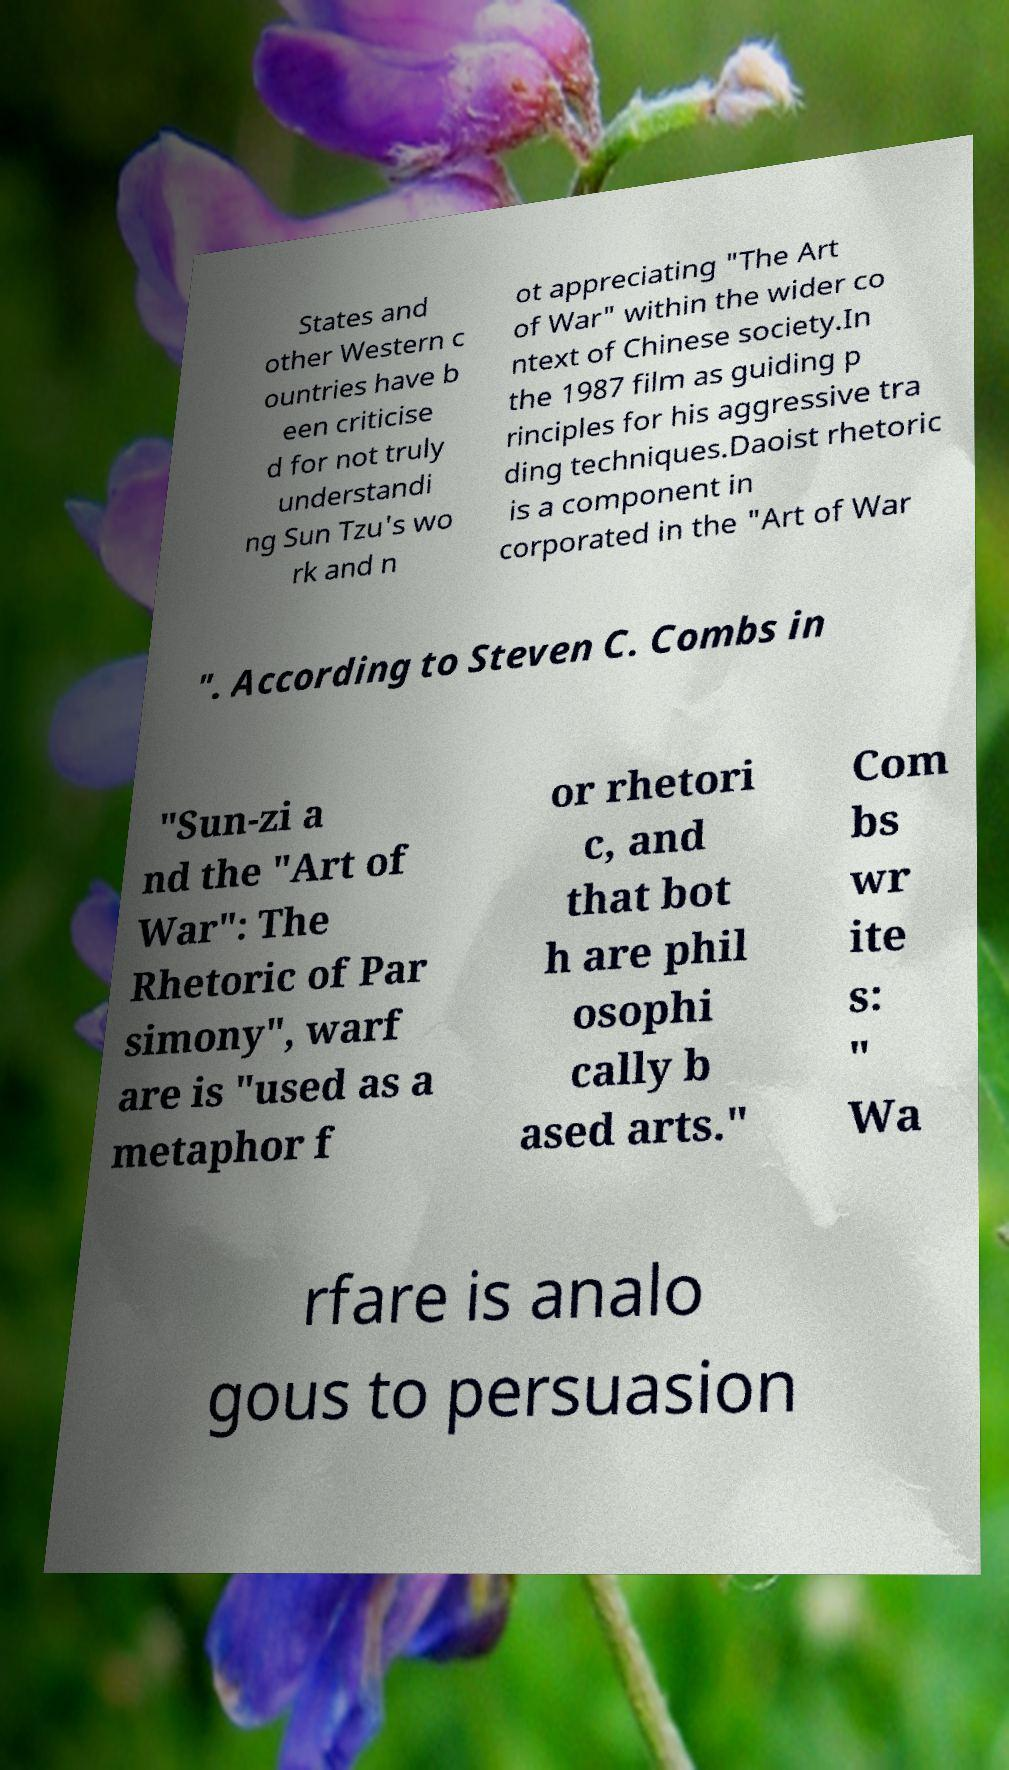Could you extract and type out the text from this image? States and other Western c ountries have b een criticise d for not truly understandi ng Sun Tzu's wo rk and n ot appreciating "The Art of War" within the wider co ntext of Chinese society.In the 1987 film as guiding p rinciples for his aggressive tra ding techniques.Daoist rhetoric is a component in corporated in the "Art of War ". According to Steven C. Combs in "Sun-zi a nd the "Art of War": The Rhetoric of Par simony", warf are is "used as a metaphor f or rhetori c, and that bot h are phil osophi cally b ased arts." Com bs wr ite s: " Wa rfare is analo gous to persuasion 